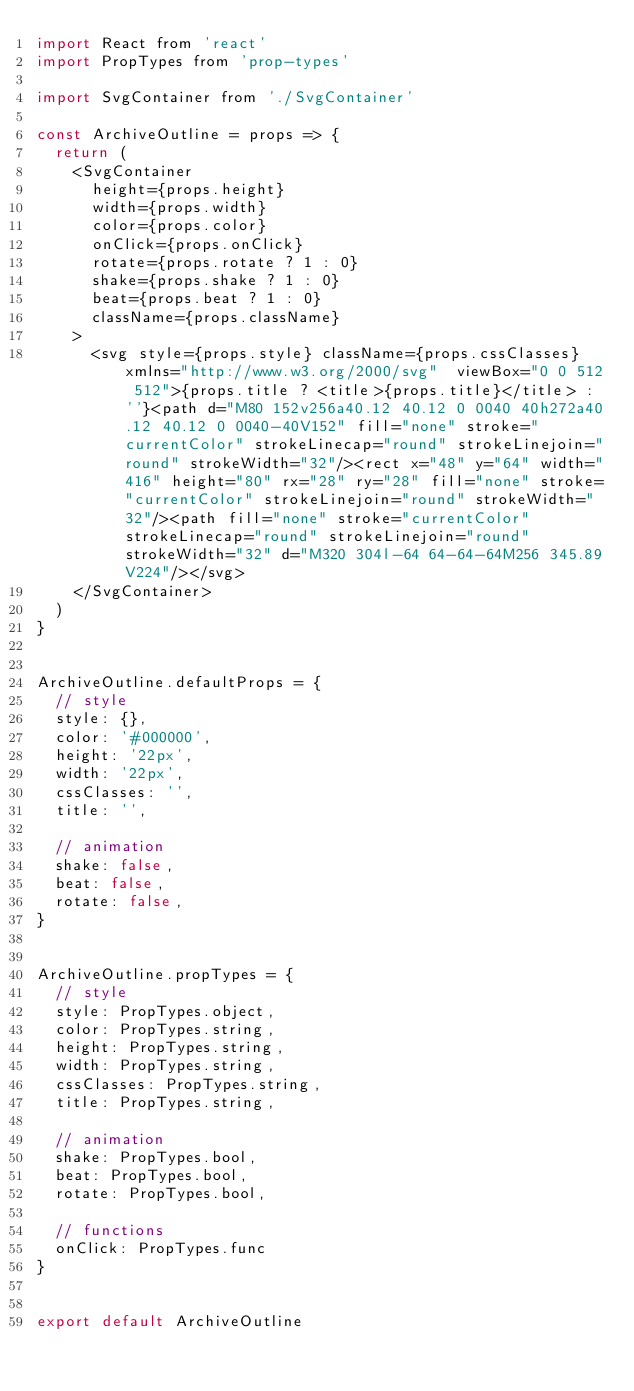Convert code to text. <code><loc_0><loc_0><loc_500><loc_500><_JavaScript_>import React from 'react'
import PropTypes from 'prop-types'

import SvgContainer from './SvgContainer'

const ArchiveOutline = props => {
  return (
    <SvgContainer
      height={props.height}
      width={props.width}
      color={props.color}
      onClick={props.onClick}
      rotate={props.rotate ? 1 : 0}
      shake={props.shake ? 1 : 0}
      beat={props.beat ? 1 : 0}
      className={props.className}
    >
      <svg style={props.style} className={props.cssClasses} xmlns="http://www.w3.org/2000/svg"  viewBox="0 0 512 512">{props.title ? <title>{props.title}</title> : ''}<path d="M80 152v256a40.12 40.12 0 0040 40h272a40.12 40.12 0 0040-40V152" fill="none" stroke="currentColor" strokeLinecap="round" strokeLinejoin="round" strokeWidth="32"/><rect x="48" y="64" width="416" height="80" rx="28" ry="28" fill="none" stroke="currentColor" strokeLinejoin="round" strokeWidth="32"/><path fill="none" stroke="currentColor" strokeLinecap="round" strokeLinejoin="round" strokeWidth="32" d="M320 304l-64 64-64-64M256 345.89V224"/></svg>
    </SvgContainer>
  )
}


ArchiveOutline.defaultProps = {
  // style
  style: {},
  color: '#000000',
  height: '22px',
  width: '22px',
  cssClasses: '',
  title: '',

  // animation
  shake: false,
  beat: false,
  rotate: false,
}


ArchiveOutline.propTypes = {
  // style
  style: PropTypes.object,
  color: PropTypes.string,
  height: PropTypes.string,
  width: PropTypes.string,
  cssClasses: PropTypes.string,
  title: PropTypes.string,

  // animation
  shake: PropTypes.bool,
  beat: PropTypes.bool,
  rotate: PropTypes.bool,

  // functions
  onClick: PropTypes.func
}


export default ArchiveOutline</code> 